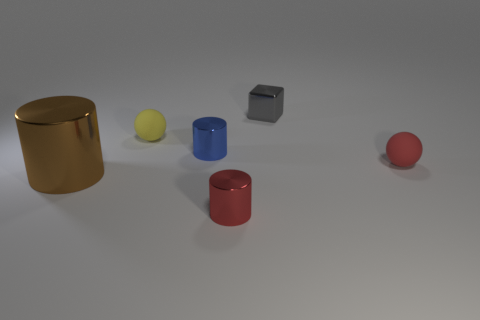Is the blue metallic thing the same size as the brown metal thing?
Your answer should be very brief. No. There is a tiny object that is in front of the tiny blue metallic thing and to the left of the tiny red sphere; what material is it made of?
Your response must be concise. Metal. How many other matte objects are the same shape as the red rubber object?
Keep it short and to the point. 1. What material is the tiny ball in front of the tiny yellow matte sphere?
Offer a very short reply. Rubber. Is the number of cylinders on the left side of the cube less than the number of blocks?
Give a very brief answer. No. Is the shape of the small gray thing the same as the blue shiny object?
Your answer should be compact. No. Is there anything else that has the same shape as the gray thing?
Offer a very short reply. No. Is there a small purple matte ball?
Your answer should be compact. No. There is a small yellow object; is it the same shape as the small red metal thing that is on the left side of the red matte sphere?
Your answer should be compact. No. What is the material of the tiny cylinder that is in front of the red thing that is behind the big brown cylinder?
Give a very brief answer. Metal. 